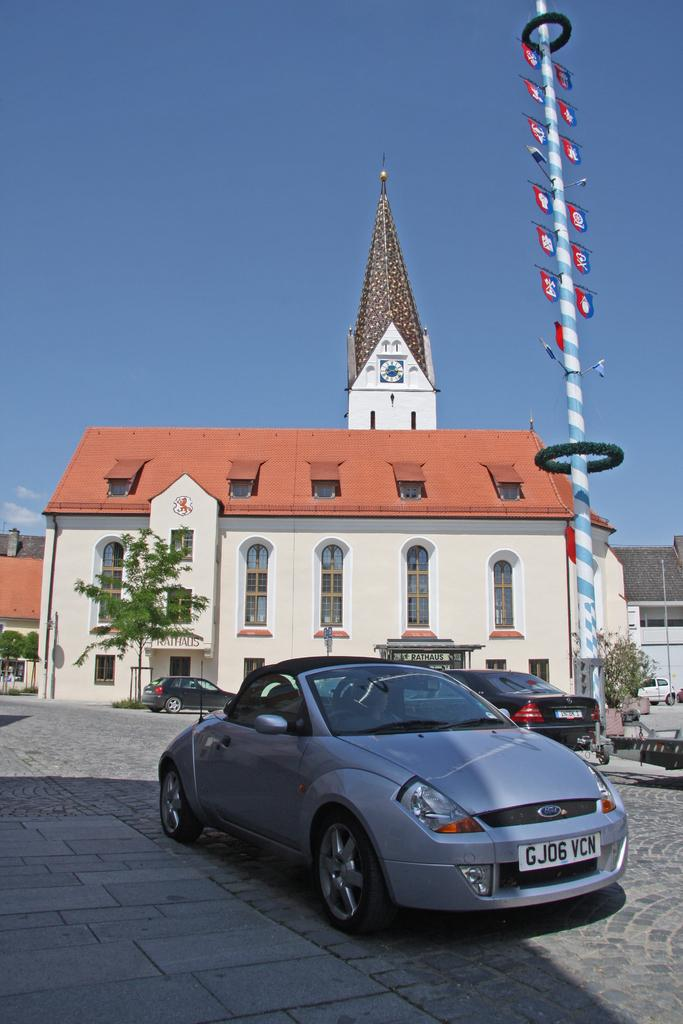What types of objects are on the ground in the image? There are vehicles on the ground in the image. What can be seen in the background of the image? There are houses, trees, a pole, and the sky visible in the background of the image. Can you describe the unspecified objects in the background of the image? Unfortunately, the provided facts do not specify the nature of these objects. How many attempts were made to build the railway in the image? There is no railway present in the image, so it is not possible to answer that question. 